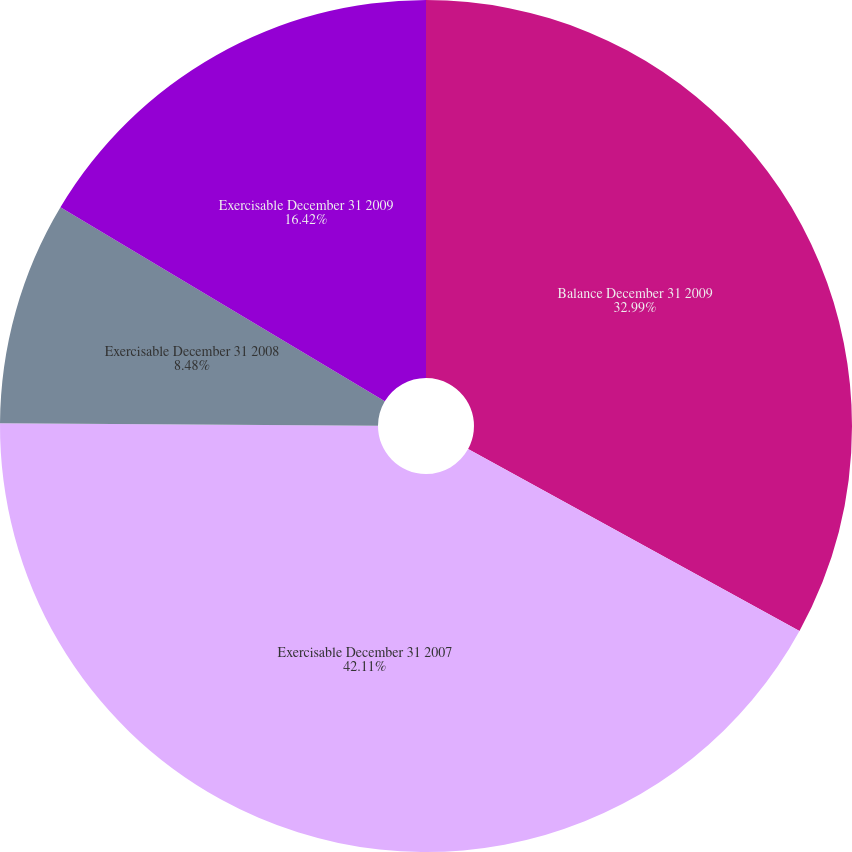Convert chart. <chart><loc_0><loc_0><loc_500><loc_500><pie_chart><fcel>Balance December 31 2009<fcel>Exercisable December 31 2007<fcel>Exercisable December 31 2008<fcel>Exercisable December 31 2009<nl><fcel>32.99%<fcel>42.12%<fcel>8.48%<fcel>16.42%<nl></chart> 